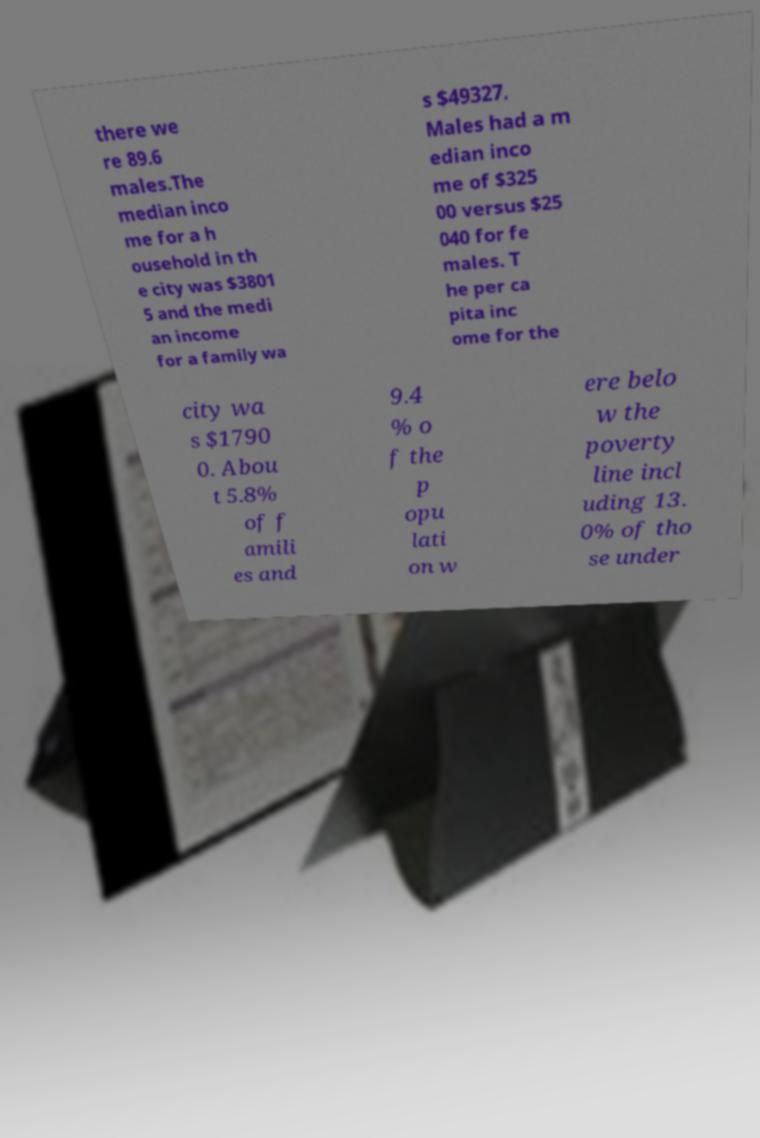For documentation purposes, I need the text within this image transcribed. Could you provide that? there we re 89.6 males.The median inco me for a h ousehold in th e city was $3801 5 and the medi an income for a family wa s $49327. Males had a m edian inco me of $325 00 versus $25 040 for fe males. T he per ca pita inc ome for the city wa s $1790 0. Abou t 5.8% of f amili es and 9.4 % o f the p opu lati on w ere belo w the poverty line incl uding 13. 0% of tho se under 